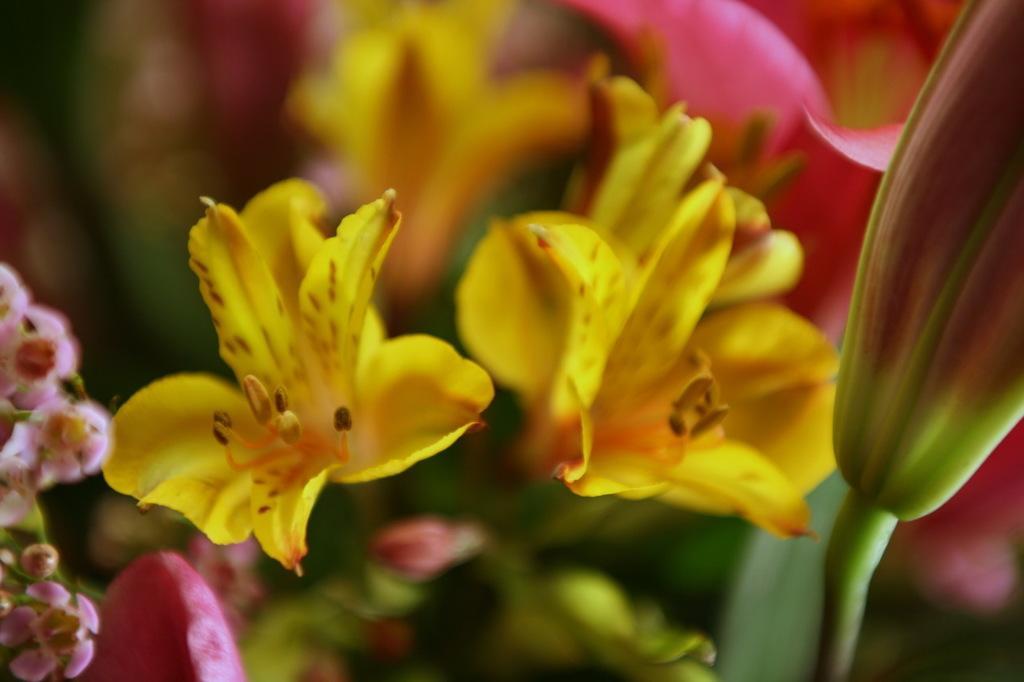Describe this image in one or two sentences. In this image there are flowers, in the background it is blurred. 